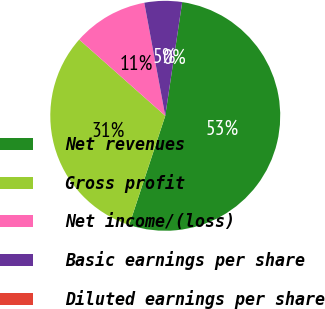Convert chart to OTSL. <chart><loc_0><loc_0><loc_500><loc_500><pie_chart><fcel>Net revenues<fcel>Gross profit<fcel>Net income/(loss)<fcel>Basic earnings per share<fcel>Diluted earnings per share<nl><fcel>52.72%<fcel>31.46%<fcel>10.54%<fcel>5.27%<fcel>0.0%<nl></chart> 